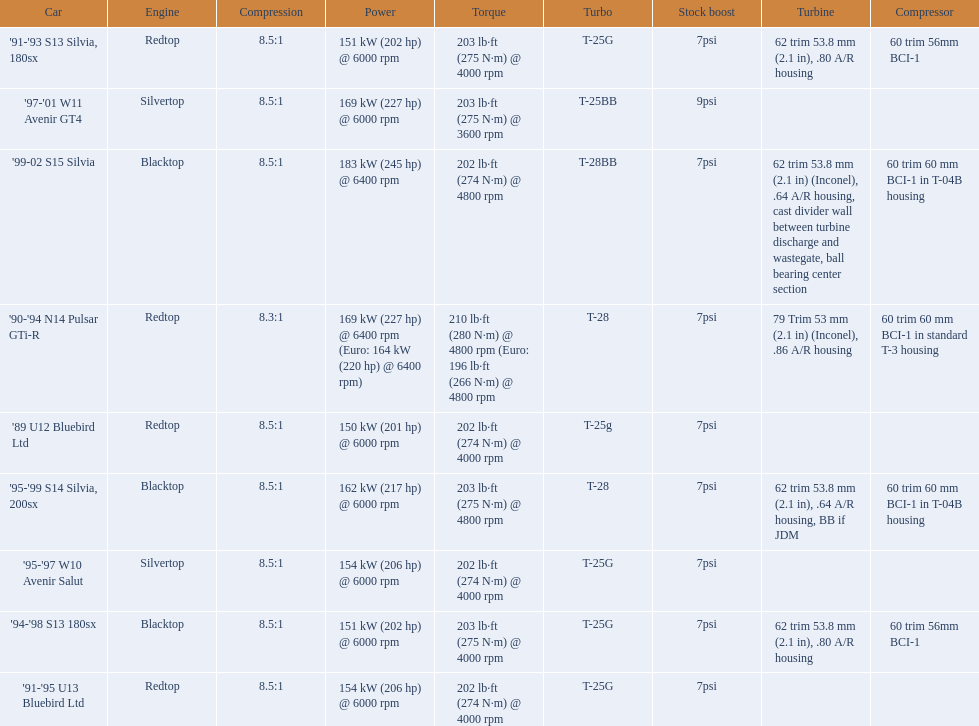What are the listed hp of the cars? 150 kW (201 hp) @ 6000 rpm, 154 kW (206 hp) @ 6000 rpm, 154 kW (206 hp) @ 6000 rpm, 169 kW (227 hp) @ 6000 rpm, 169 kW (227 hp) @ 6400 rpm (Euro: 164 kW (220 hp) @ 6400 rpm), 151 kW (202 hp) @ 6000 rpm, 151 kW (202 hp) @ 6000 rpm, 162 kW (217 hp) @ 6000 rpm, 183 kW (245 hp) @ 6400 rpm. Which is the only car with over 230 hp? '99-02 S15 Silvia. 